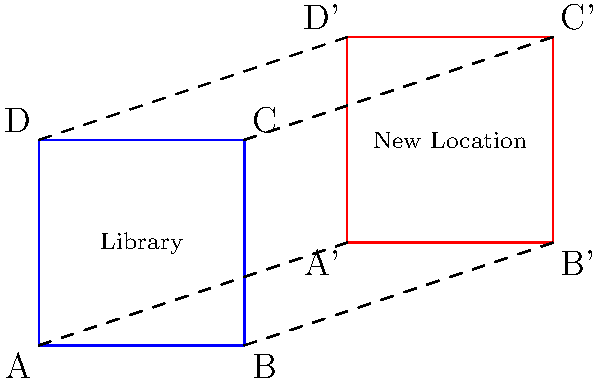As a book lover and social worker, you're helping to relocate a library. The diagram shows the original library layout (blue square ABCD) and its new location (red square A'B'C'D'). Describe the sequence of transformations that maps the original library icon to its new location, considering the movement's focus on efficient space utilization. Let's approach this step-by-step:

1) First, observe the change in position and size of the square:
   - The square has moved to the right and up.
   - The size of the square remains the same.

2) Translation:
   - The square has moved 6 units to the right and 2 units up.
   - This can be represented as a translation by the vector $(6,2)$.

3) Rotation:
   - There is no rotation involved as the sides of the square remain parallel to their original orientation.

4) Reflection:
   - There is no reflection as the orientation of the square hasn't changed.

5) Dilation:
   - The size of the square remains the same, so there is no dilation.

Therefore, the only transformation applied is a translation.

In mathematical terms:
$T_{(6,2)}(x,y) = (x+6, y+2)$

This transformation maps:
$A(0,0)$ to $A'(6,2)$
$B(4,0)$ to $B'(10,2)$
$C(4,4)$ to $C'(10,6)$
$D(0,4)$ to $D'(6,6)$

This transformation ensures efficient space utilization by maintaining the original layout while moving it to the new location.
Answer: Translation by vector $(6,2)$ 